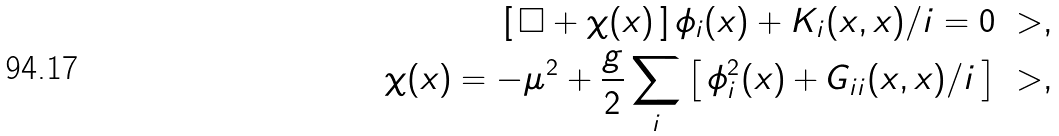Convert formula to latex. <formula><loc_0><loc_0><loc_500><loc_500>[ \, \Box + \chi ( x ) \, ] \, \phi _ { i } ( x ) + K _ { i } ( x , x ) / i = 0 \ > , \\ \chi ( x ) = - \mu ^ { 2 } + \frac { g } { 2 } \sum _ { i } \left [ \, \phi _ { i } ^ { 2 } ( x ) + G _ { i i } ( x , x ) / i \, \right ] \ > ,</formula> 